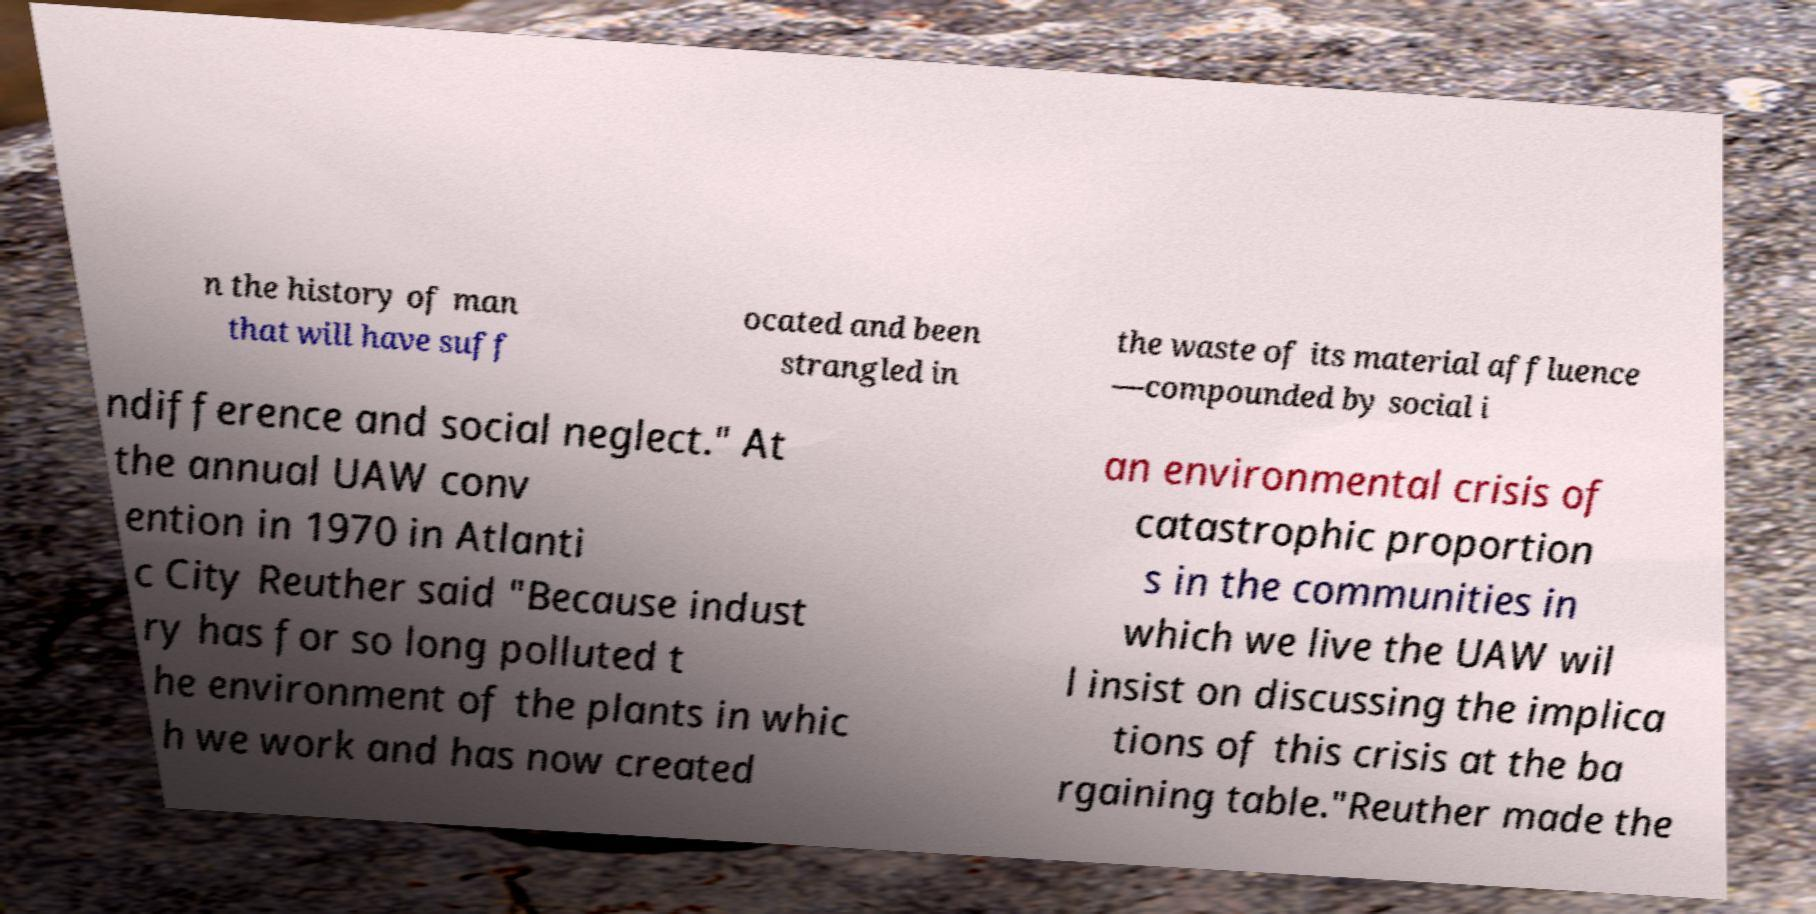Can you read and provide the text displayed in the image?This photo seems to have some interesting text. Can you extract and type it out for me? n the history of man that will have suff ocated and been strangled in the waste of its material affluence —compounded by social i ndifference and social neglect." At the annual UAW conv ention in 1970 in Atlanti c City Reuther said "Because indust ry has for so long polluted t he environment of the plants in whic h we work and has now created an environmental crisis of catastrophic proportion s in the communities in which we live the UAW wil l insist on discussing the implica tions of this crisis at the ba rgaining table."Reuther made the 